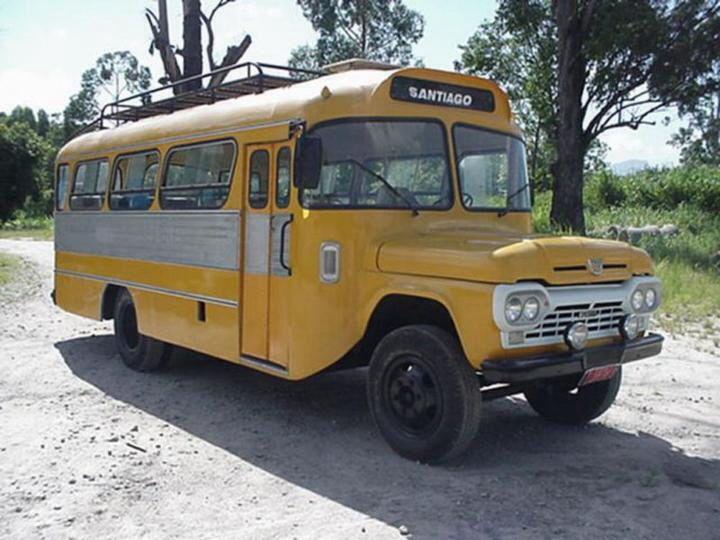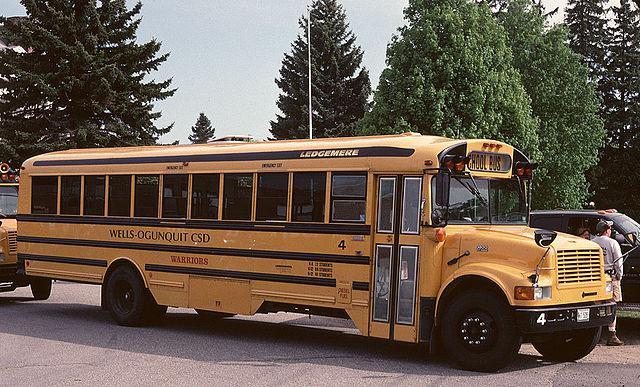The first image is the image on the left, the second image is the image on the right. For the images displayed, is the sentence "The left image shows an angled, forward-facing bus with rust and other condition issues, and the right image features a leftward-angled bus in good condition." factually correct? Answer yes or no. No. The first image is the image on the left, the second image is the image on the right. Considering the images on both sides, is "There are at least 12 window on the rusted out bus." valid? Answer yes or no. No. 